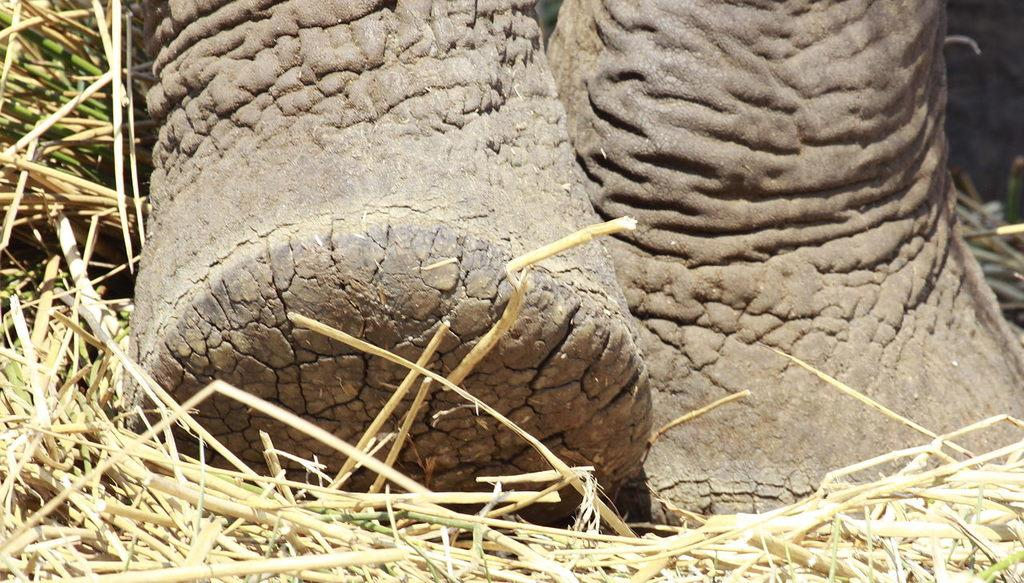What is the main subject in the center of the image? There are elephant legs in the center of the image. What type of vegetation is visible at the bottom of the image? There is grass at the bottom of the image. What type of canvas is the manager using to paint the visitor in the image? There is no canvas, manager, or visitor present in the image; it only features elephant legs and grass. 